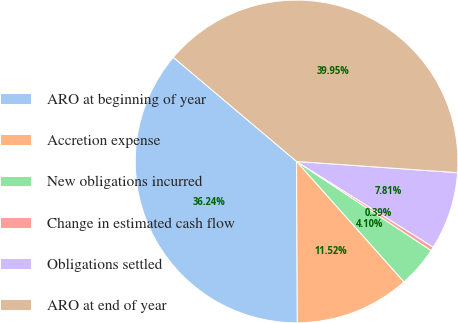<chart> <loc_0><loc_0><loc_500><loc_500><pie_chart><fcel>ARO at beginning of year<fcel>Accretion expense<fcel>New obligations incurred<fcel>Change in estimated cash flow<fcel>Obligations settled<fcel>ARO at end of year<nl><fcel>36.24%<fcel>11.52%<fcel>4.1%<fcel>0.39%<fcel>7.81%<fcel>39.95%<nl></chart> 